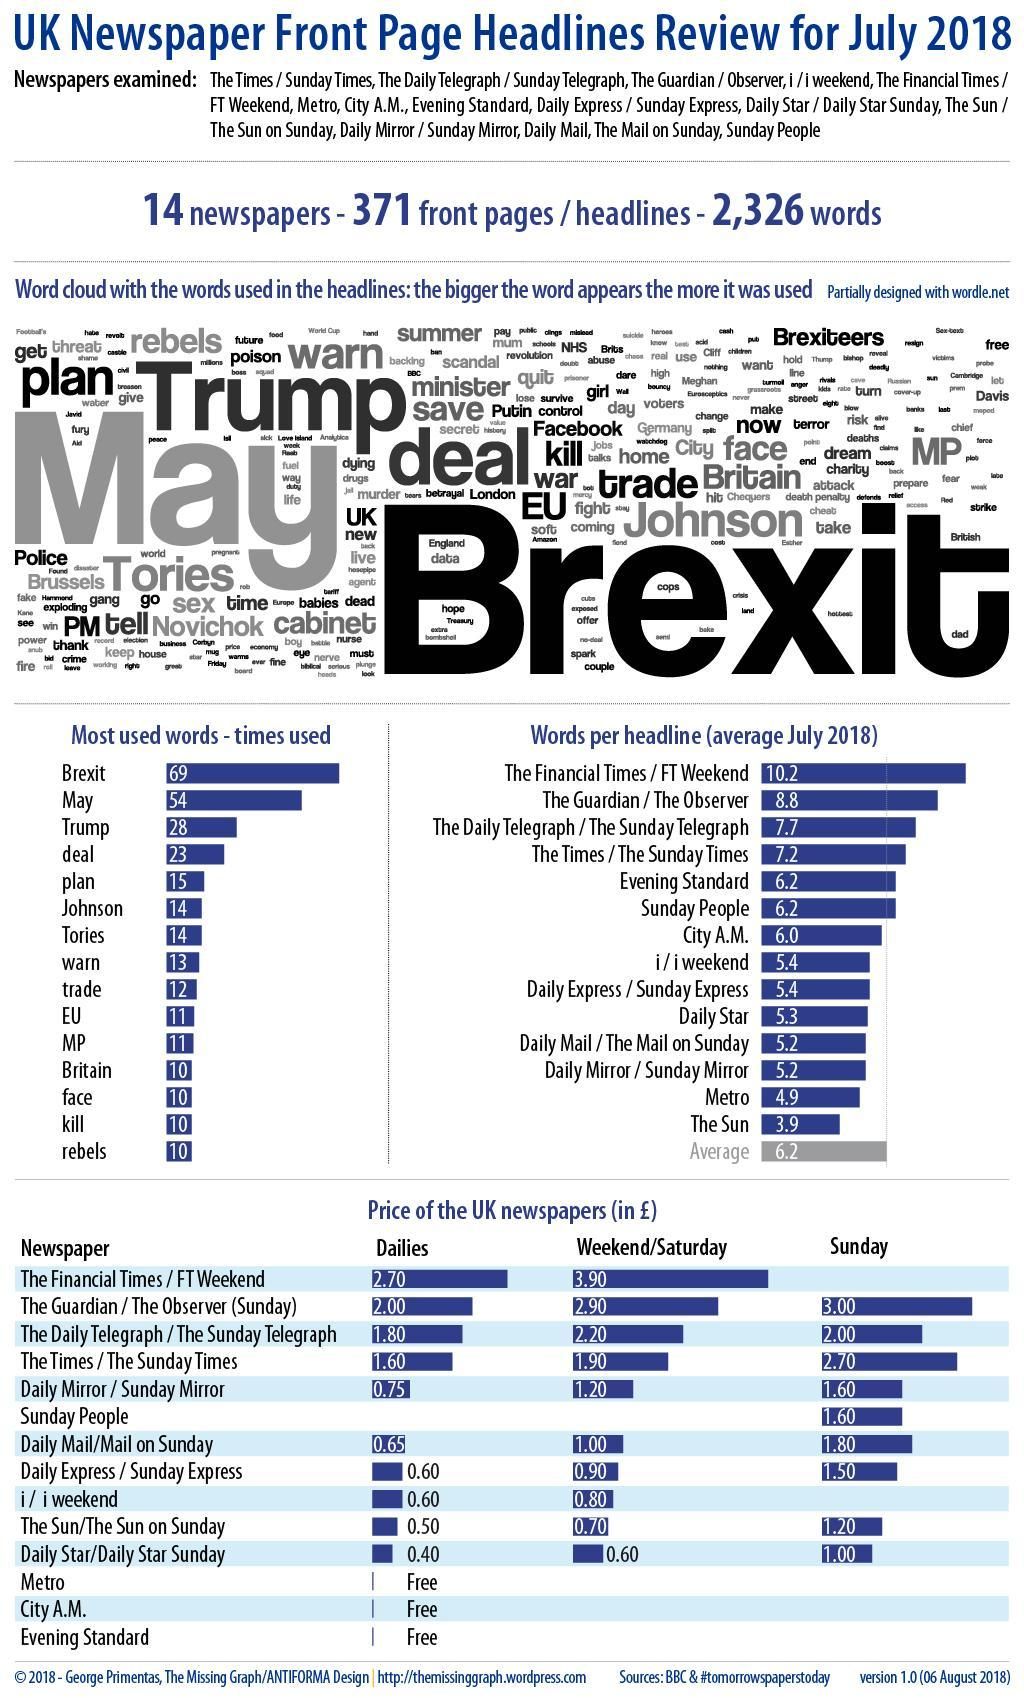How many words in the list have number of times used as 10?
Answer the question with a short phrase. 4 which is the second most used word? May Which word is used twice the number of times as Johnson? Trump How many words are there in the list that are used more than 50 times? 2 How many words are there in the most used words list? 15 